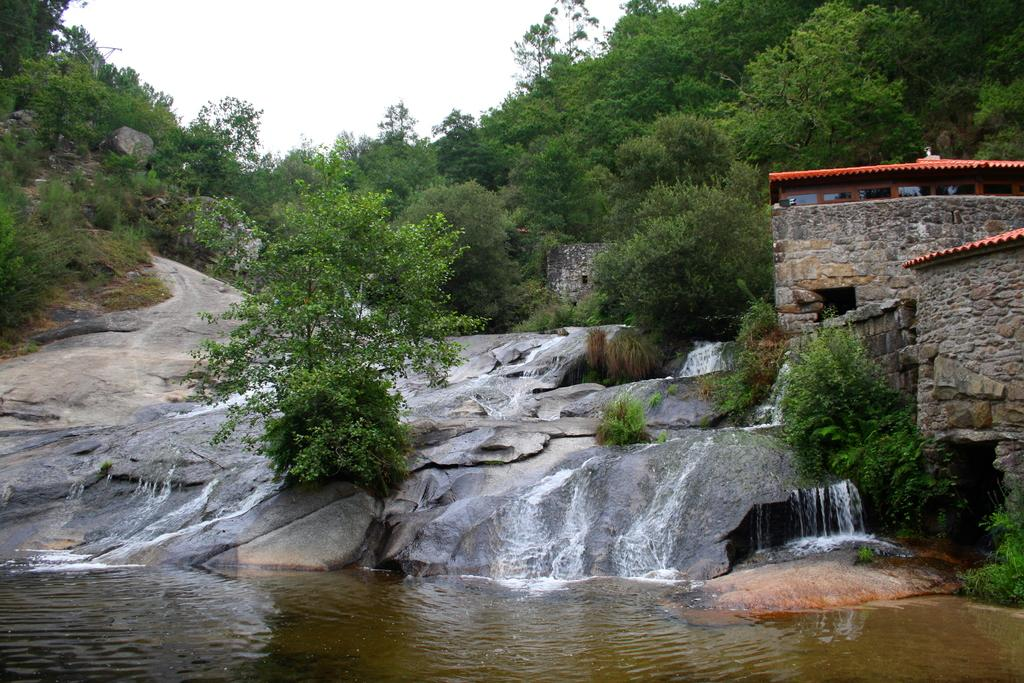What type of vegetation can be seen in the image? There are trees in the image. What geological feature is present in the image? There is a rock in the image. What natural element is visible in the image? Water is visible in the image. What part of the natural environment is visible in the image? The sky is visible in the image. What type of man-made structures are present in the image? There are houses in the image. What type of battle is taking place in the image? There is no battle present in the image; it features trees, a rock, water, sky, and houses. What type of hope can be seen in the image? There is no specific hope depicted in the image; it is a scene of natural and man-made elements. 